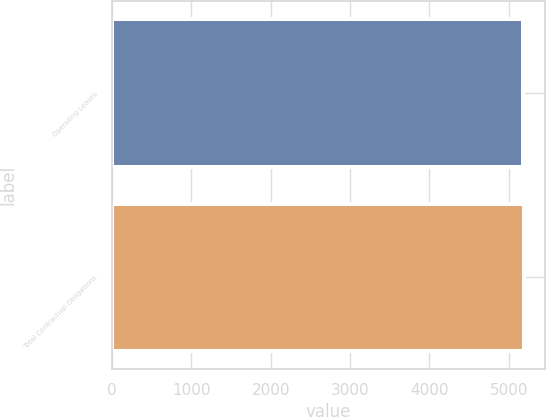<chart> <loc_0><loc_0><loc_500><loc_500><bar_chart><fcel>Operating Leases<fcel>Total Contractual Obligations<nl><fcel>5174<fcel>5194<nl></chart> 